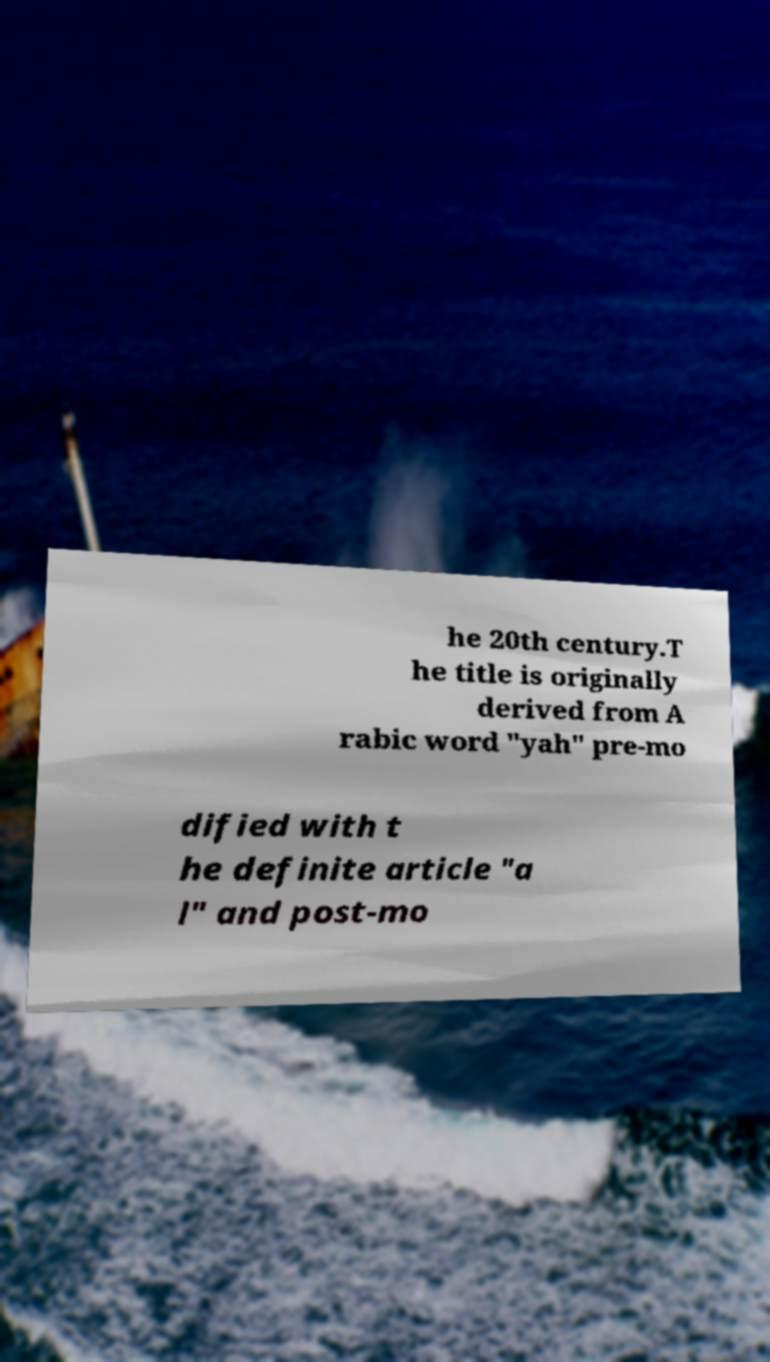Please identify and transcribe the text found in this image. he 20th century.T he title is originally derived from A rabic word "yah" pre-mo dified with t he definite article "a l" and post-mo 